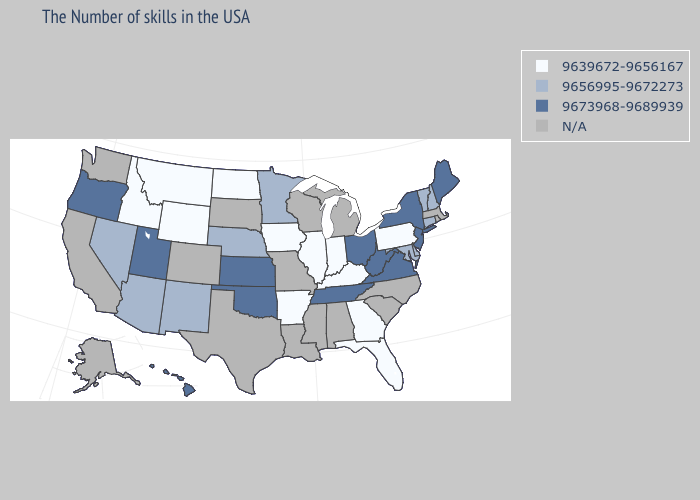Name the states that have a value in the range 9656995-9672273?
Answer briefly. New Hampshire, Vermont, Connecticut, Delaware, Maryland, Minnesota, Nebraska, New Mexico, Arizona, Nevada. Which states hav the highest value in the Northeast?
Quick response, please. Maine, New York, New Jersey. What is the value of Missouri?
Give a very brief answer. N/A. What is the highest value in the USA?
Keep it brief. 9673968-9689939. Which states have the highest value in the USA?
Write a very short answer. Maine, New York, New Jersey, Virginia, West Virginia, Ohio, Tennessee, Kansas, Oklahoma, Utah, Oregon, Hawaii. What is the highest value in the South ?
Keep it brief. 9673968-9689939. Is the legend a continuous bar?
Keep it brief. No. Among the states that border South Dakota , does Minnesota have the highest value?
Answer briefly. Yes. Which states have the lowest value in the Northeast?
Short answer required. Pennsylvania. Is the legend a continuous bar?
Quick response, please. No. What is the value of Idaho?
Give a very brief answer. 9639672-9656167. Among the states that border New Mexico , which have the highest value?
Concise answer only. Oklahoma, Utah. What is the value of New York?
Short answer required. 9673968-9689939. What is the value of South Carolina?
Give a very brief answer. N/A. 